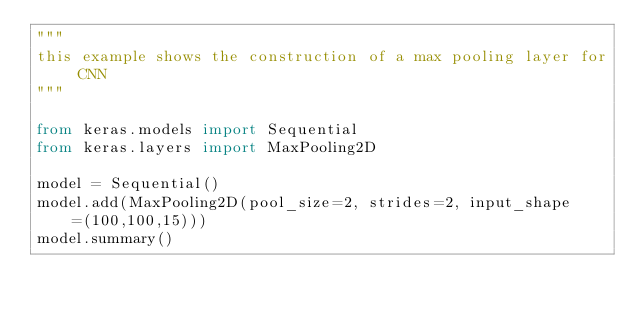Convert code to text. <code><loc_0><loc_0><loc_500><loc_500><_Python_>"""
this example shows the construction of a max pooling layer for CNN
"""

from keras.models import Sequential
from keras.layers import MaxPooling2D

model = Sequential()
model.add(MaxPooling2D(pool_size=2, strides=2, input_shape=(100,100,15)))
model.summary()

</code> 